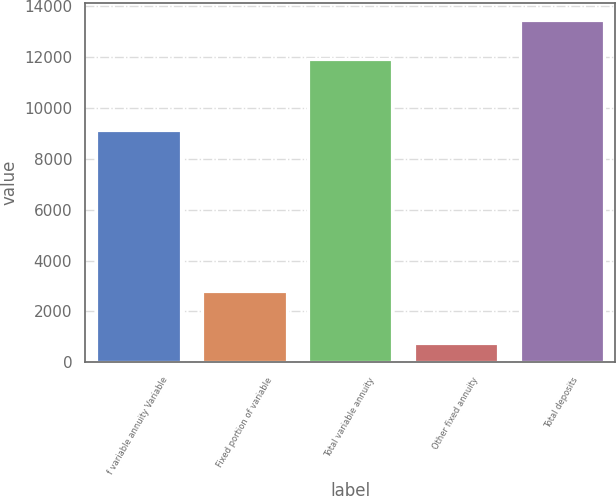Convert chart to OTSL. <chart><loc_0><loc_0><loc_500><loc_500><bar_chart><fcel>f variable annuity Variable<fcel>Fixed portion of variable<fcel>Total variable annuity<fcel>Other fixed annuity<fcel>Total deposits<nl><fcel>9135<fcel>2795<fcel>11930<fcel>772<fcel>13457<nl></chart> 